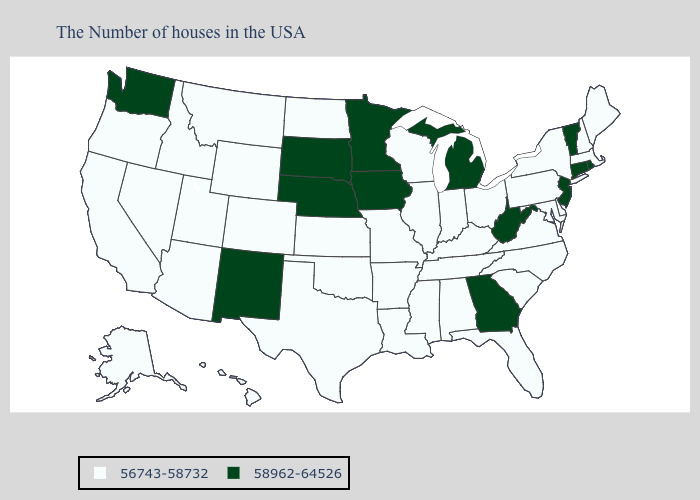Which states have the lowest value in the USA?
Answer briefly. Maine, Massachusetts, New Hampshire, New York, Delaware, Maryland, Pennsylvania, Virginia, North Carolina, South Carolina, Ohio, Florida, Kentucky, Indiana, Alabama, Tennessee, Wisconsin, Illinois, Mississippi, Louisiana, Missouri, Arkansas, Kansas, Oklahoma, Texas, North Dakota, Wyoming, Colorado, Utah, Montana, Arizona, Idaho, Nevada, California, Oregon, Alaska, Hawaii. Name the states that have a value in the range 58962-64526?
Be succinct. Rhode Island, Vermont, Connecticut, New Jersey, West Virginia, Georgia, Michigan, Minnesota, Iowa, Nebraska, South Dakota, New Mexico, Washington. Does the map have missing data?
Answer briefly. No. Among the states that border Nevada , which have the lowest value?
Short answer required. Utah, Arizona, Idaho, California, Oregon. Does Oregon have the same value as Minnesota?
Quick response, please. No. Among the states that border Kansas , does Nebraska have the lowest value?
Give a very brief answer. No. How many symbols are there in the legend?
Keep it brief. 2. What is the value of Hawaii?
Short answer required. 56743-58732. Does the map have missing data?
Write a very short answer. No. Among the states that border Kentucky , does Tennessee have the highest value?
Quick response, please. No. Name the states that have a value in the range 56743-58732?
Answer briefly. Maine, Massachusetts, New Hampshire, New York, Delaware, Maryland, Pennsylvania, Virginia, North Carolina, South Carolina, Ohio, Florida, Kentucky, Indiana, Alabama, Tennessee, Wisconsin, Illinois, Mississippi, Louisiana, Missouri, Arkansas, Kansas, Oklahoma, Texas, North Dakota, Wyoming, Colorado, Utah, Montana, Arizona, Idaho, Nevada, California, Oregon, Alaska, Hawaii. Name the states that have a value in the range 56743-58732?
Quick response, please. Maine, Massachusetts, New Hampshire, New York, Delaware, Maryland, Pennsylvania, Virginia, North Carolina, South Carolina, Ohio, Florida, Kentucky, Indiana, Alabama, Tennessee, Wisconsin, Illinois, Mississippi, Louisiana, Missouri, Arkansas, Kansas, Oklahoma, Texas, North Dakota, Wyoming, Colorado, Utah, Montana, Arizona, Idaho, Nevada, California, Oregon, Alaska, Hawaii. Does New Jersey have a higher value than Connecticut?
Quick response, please. No. What is the value of Delaware?
Concise answer only. 56743-58732. Does the first symbol in the legend represent the smallest category?
Write a very short answer. Yes. 